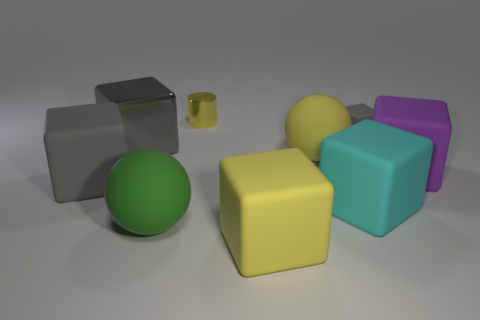The tiny rubber object that is the same color as the metallic cube is what shape?
Provide a short and direct response. Cube. What number of big objects are rubber spheres or cyan balls?
Keep it short and to the point. 2. The small thing that is the same material as the large purple object is what color?
Provide a succinct answer. Gray. What number of big gray blocks are made of the same material as the tiny yellow cylinder?
Offer a very short reply. 1. Do the gray block in front of the big yellow matte sphere and the cyan matte object that is in front of the gray metallic thing have the same size?
Offer a terse response. Yes. The big yellow thing behind the large block that is in front of the green sphere is made of what material?
Your response must be concise. Rubber. Are there fewer rubber things behind the big gray metallic block than large yellow matte things that are behind the large green ball?
Provide a succinct answer. No. There is a large sphere that is the same color as the tiny cylinder; what is its material?
Provide a succinct answer. Rubber. Are there any other things that have the same shape as the yellow metal object?
Ensure brevity in your answer.  No. What is the block that is on the right side of the small matte object made of?
Offer a terse response. Rubber. 